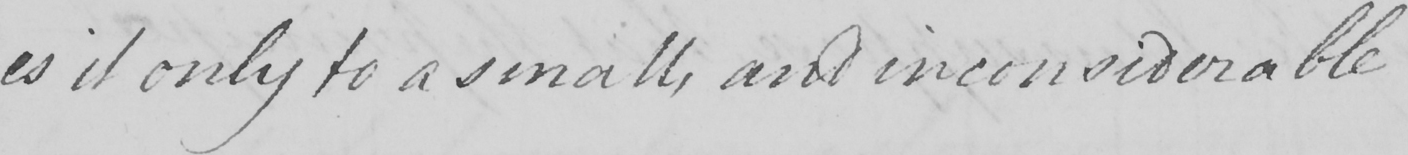Please provide the text content of this handwritten line. es it only to a small , and inconsiderable 